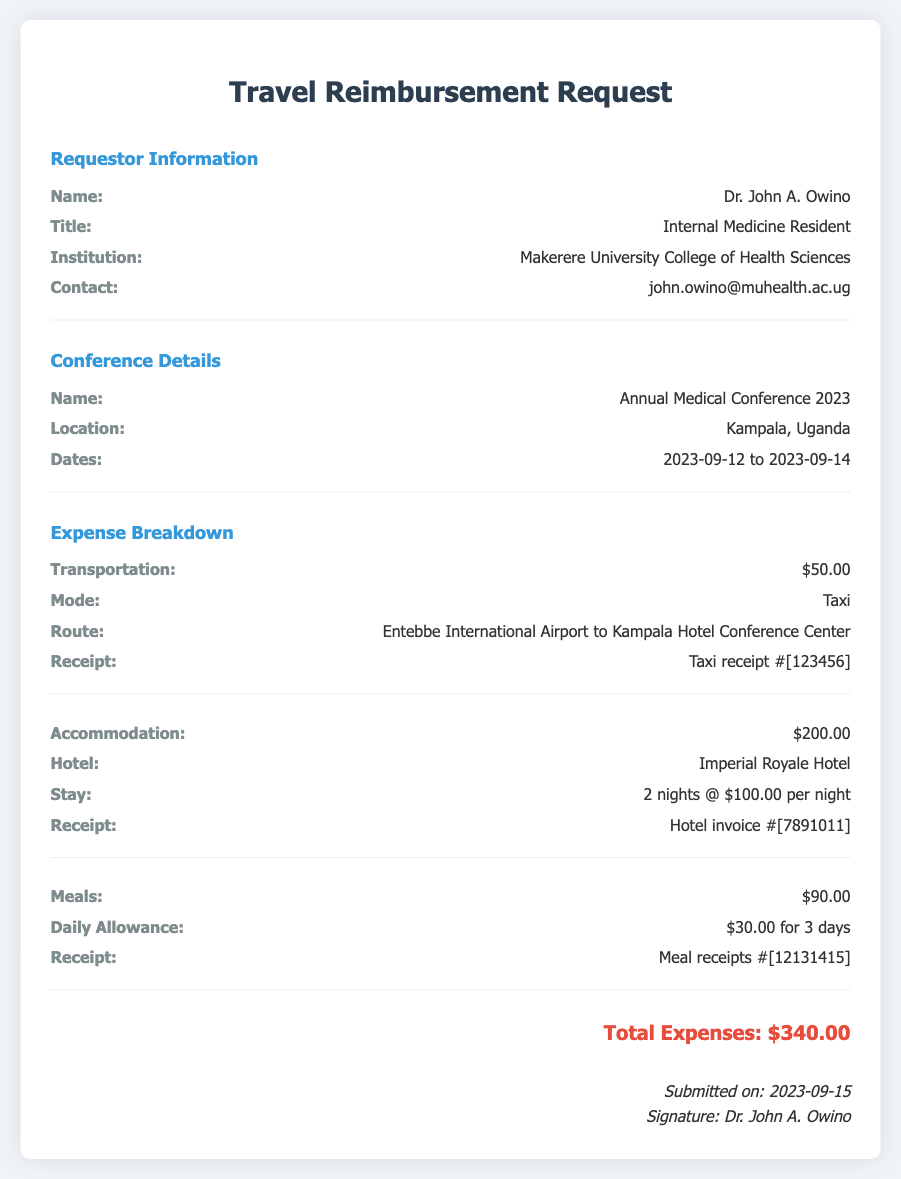what is the name of the requestor? The document specifies the name of the requestor, which is Dr. John A. Owino.
Answer: Dr. John A. Owino what is the total amount of expenses? The document lists total expenses as $340.00.
Answer: $340.00 how many nights did the accommodation last? The accommodation section indicates a stay of 2 nights.
Answer: 2 nights what was the mode of transportation? The document states that the mode of transportation was by Taxi.
Answer: Taxi what is the title of the requestor? The requestor's title is indicated in the document as Internal Medicine Resident.
Answer: Internal Medicine Resident what was the daily allowance for meals? The daily allowance for meals is specified as $30.00.
Answer: $30.00 what hotel was used for accommodation? The hotel for accommodation mentioned in the document is Imperial Royale Hotel.
Answer: Imperial Royale Hotel when was the submission date? The submission date is noted in the document as 2023-09-15.
Answer: 2023-09-15 how much was spent on transportation? The document indicates that transportation expenses amounted to $50.00.
Answer: $50.00 